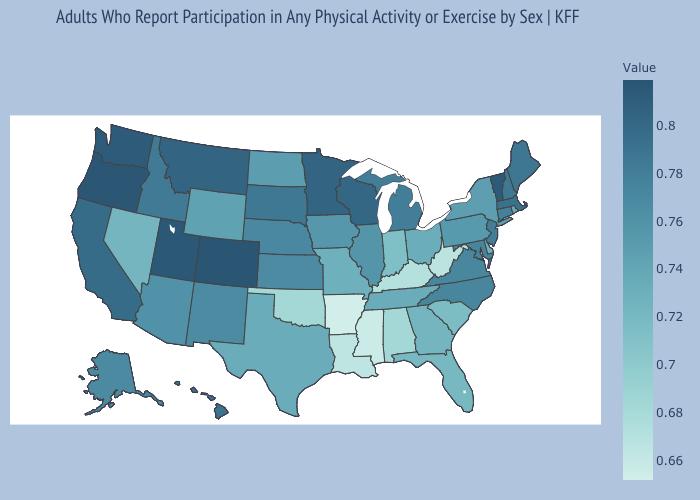Which states hav the highest value in the Northeast?
Write a very short answer. Vermont. Does Idaho have a lower value than Rhode Island?
Concise answer only. No. Which states have the lowest value in the USA?
Quick response, please. Arkansas. Among the states that border Georgia , does Florida have the lowest value?
Keep it brief. No. Which states hav the highest value in the West?
Answer briefly. Colorado. Which states hav the highest value in the South?
Be succinct. Maryland. Does Minnesota have the highest value in the MidWest?
Quick response, please. Yes. Among the states that border Delaware , which have the lowest value?
Keep it brief. Pennsylvania. Among the states that border Kansas , does Colorado have the highest value?
Short answer required. Yes. 